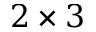Convert formula to latex. <formula><loc_0><loc_0><loc_500><loc_500>2 \times 3</formula> 